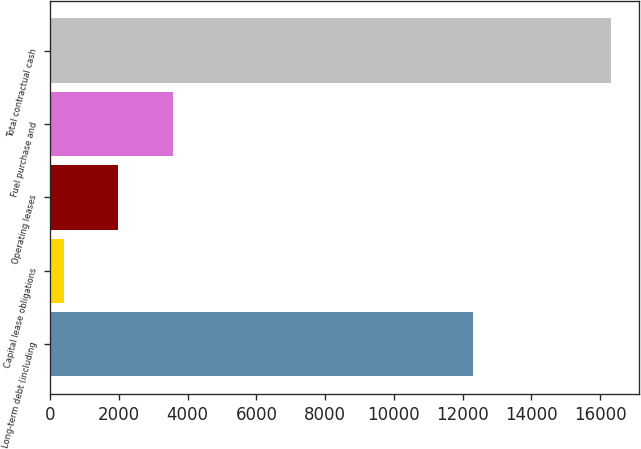Convert chart to OTSL. <chart><loc_0><loc_0><loc_500><loc_500><bar_chart><fcel>Long-term debt (including<fcel>Capital lease obligations<fcel>Operating leases<fcel>Fuel purchase and<fcel>Total contractual cash<nl><fcel>12301<fcel>390<fcel>1982.4<fcel>3574.8<fcel>16314<nl></chart> 